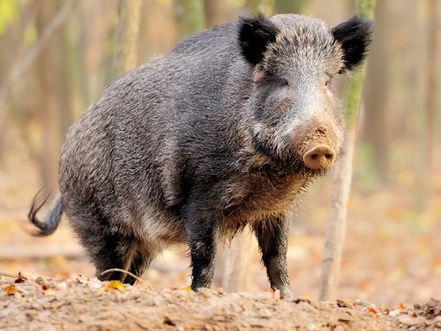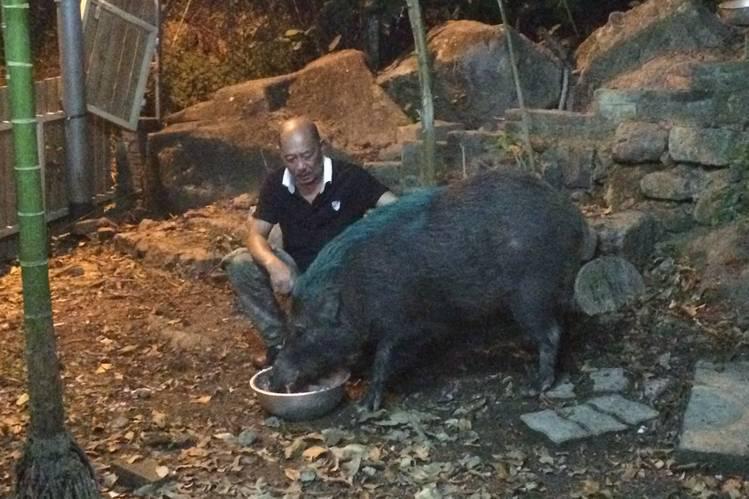The first image is the image on the left, the second image is the image on the right. For the images displayed, is the sentence "There is at least one image in which there is a person near the boar." factually correct? Answer yes or no. Yes. The first image is the image on the left, the second image is the image on the right. For the images displayed, is the sentence "There is a human feeding one of the pigs." factually correct? Answer yes or no. Yes. 